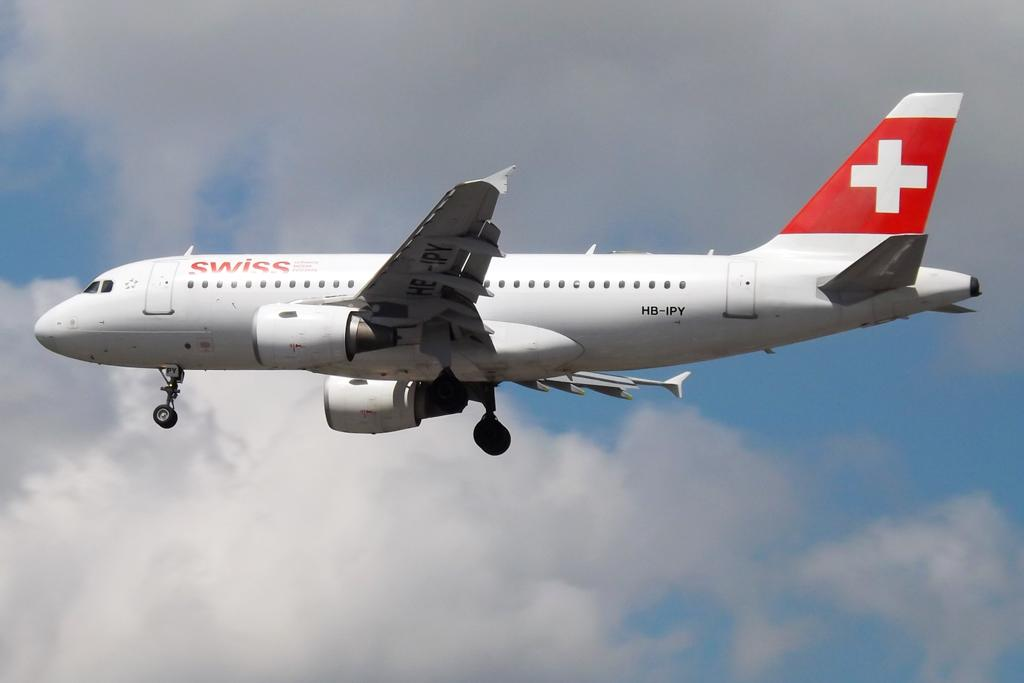<image>
Provide a brief description of the given image. The plane flying in the sky is from Swiss airlines. 